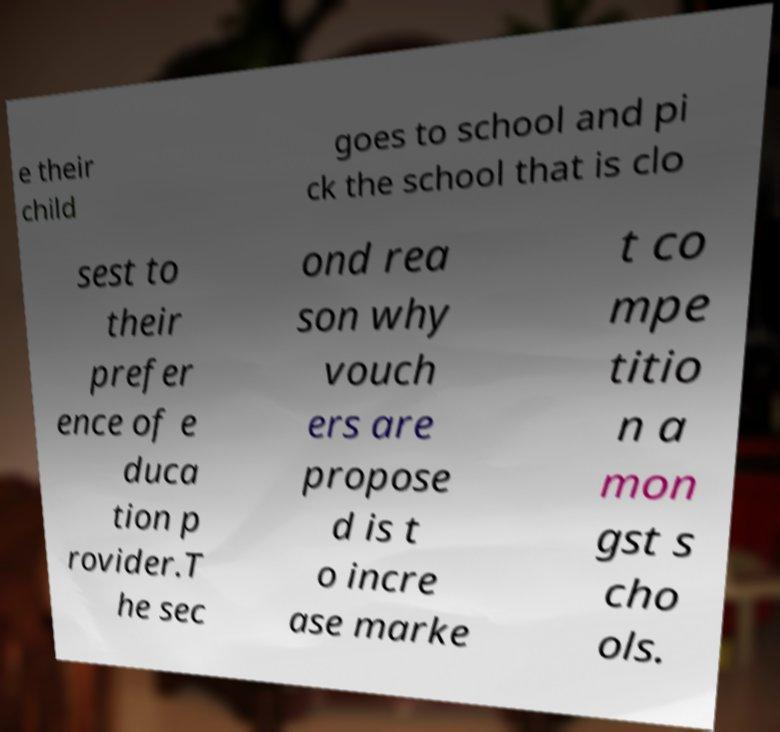Could you extract and type out the text from this image? e their child goes to school and pi ck the school that is clo sest to their prefer ence of e duca tion p rovider.T he sec ond rea son why vouch ers are propose d is t o incre ase marke t co mpe titio n a mon gst s cho ols. 